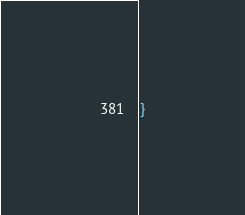Convert code to text. <code><loc_0><loc_0><loc_500><loc_500><_C_>}
</code> 